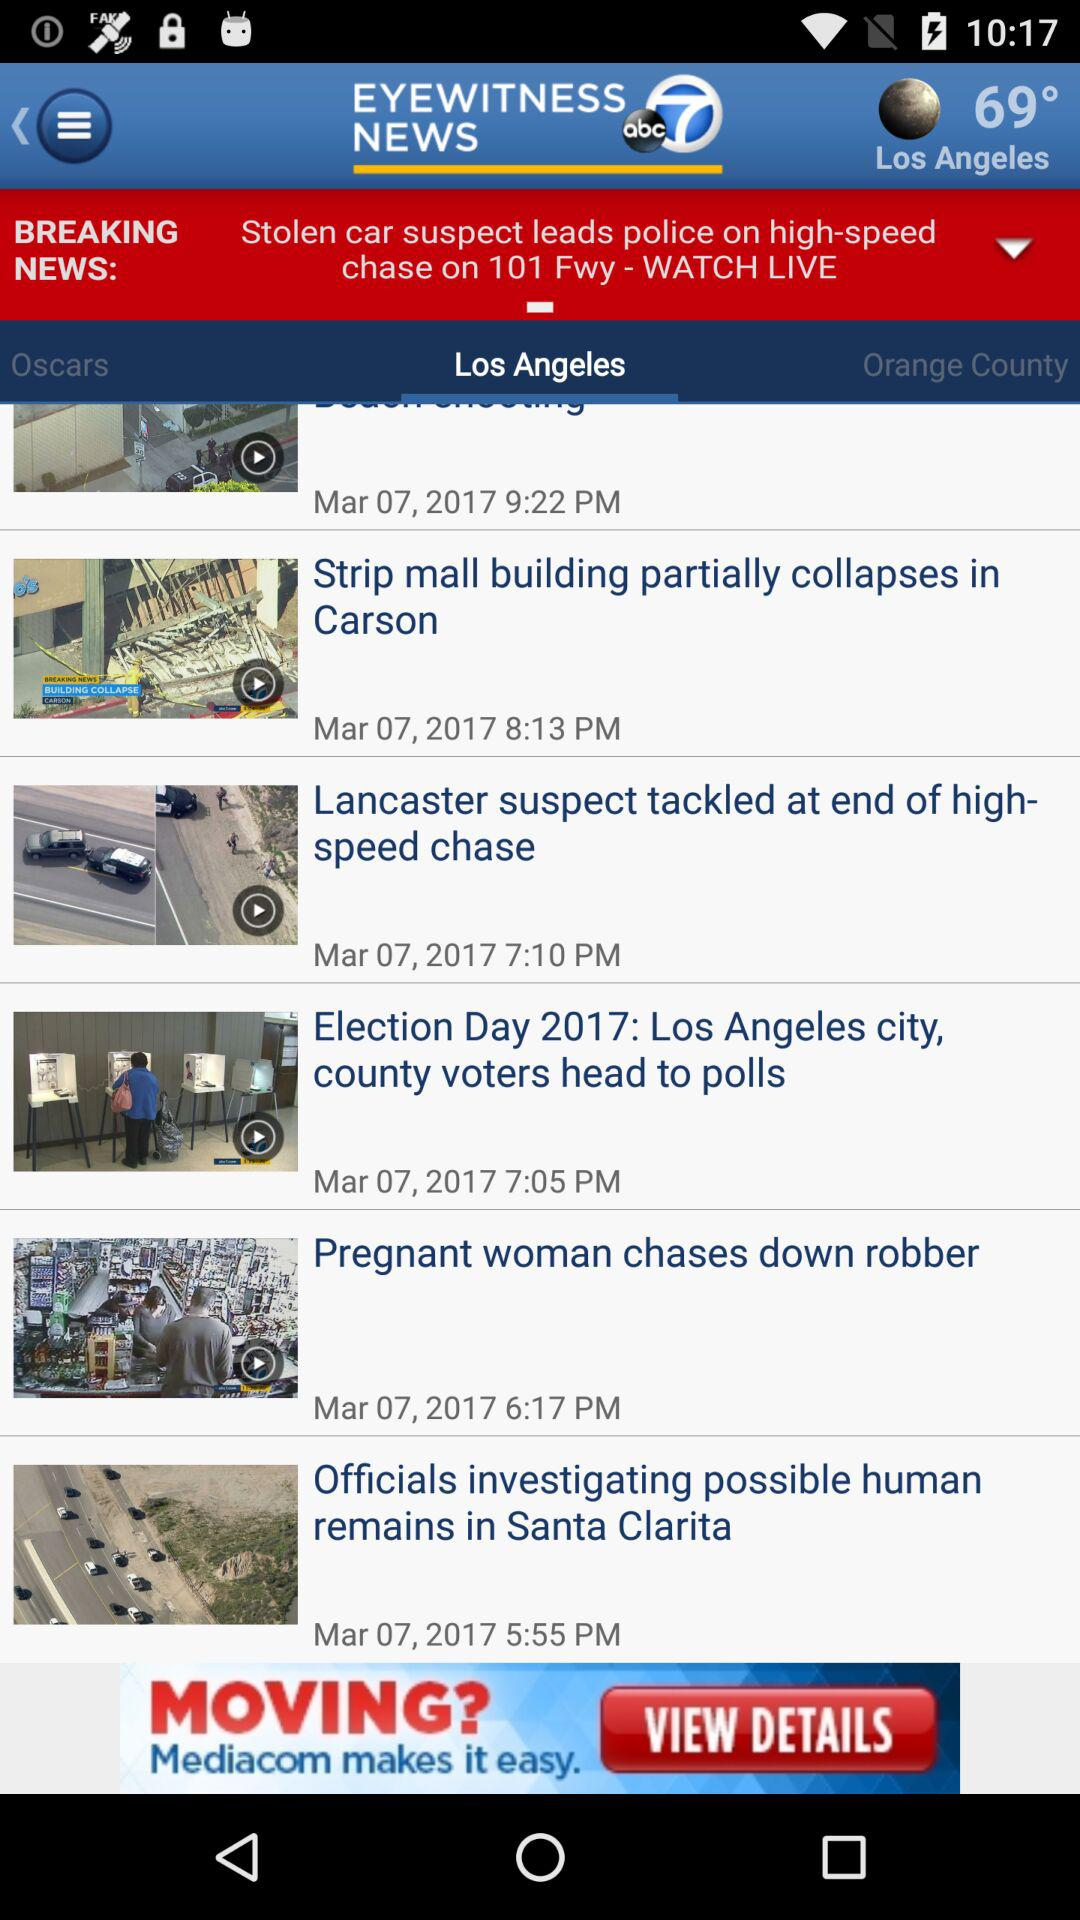What is the date of the post "Pregnant woman chases down a robber"? The date of the post "Pregnant woman chases down a robber" is March 07, 2017. 